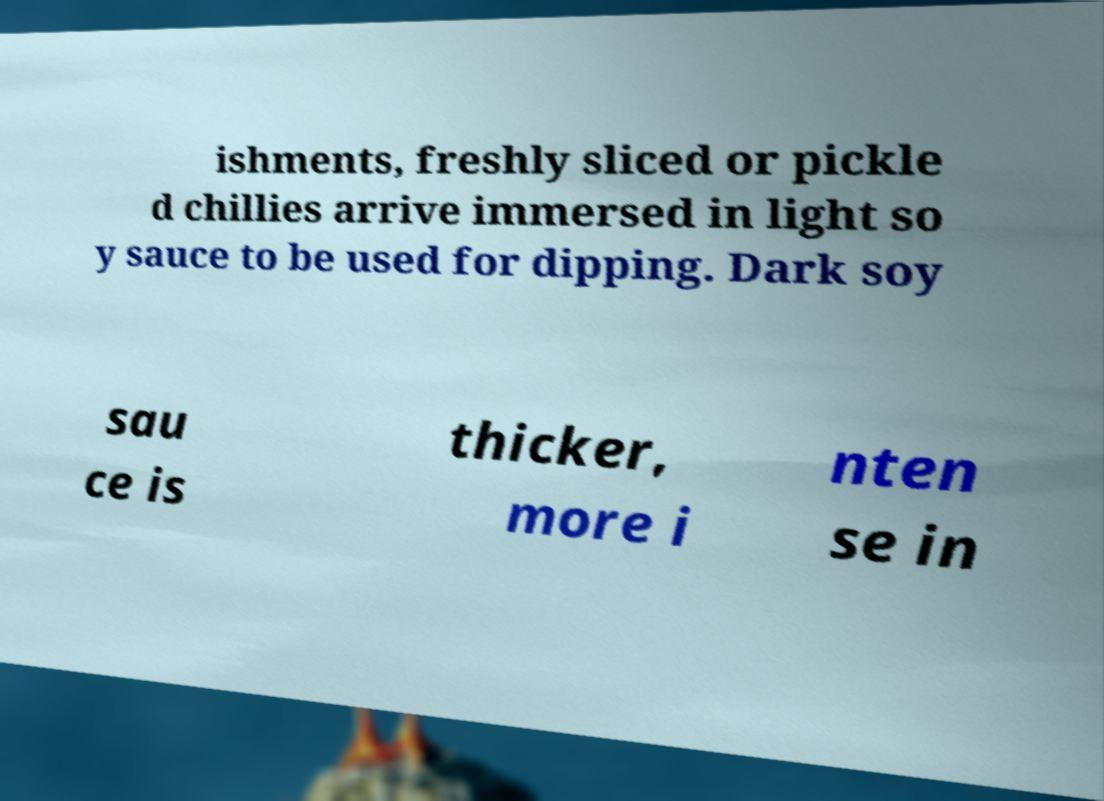I need the written content from this picture converted into text. Can you do that? ishments, freshly sliced or pickle d chillies arrive immersed in light so y sauce to be used for dipping. Dark soy sau ce is thicker, more i nten se in 